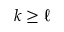Convert formula to latex. <formula><loc_0><loc_0><loc_500><loc_500>k \geq \ell</formula> 